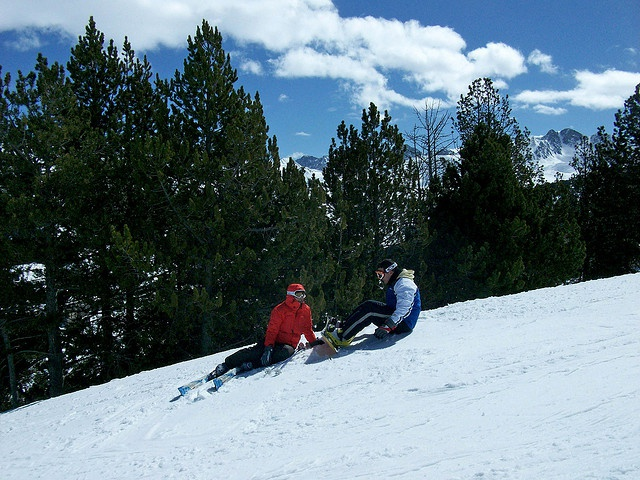Describe the objects in this image and their specific colors. I can see people in lightblue, black, navy, and gray tones, people in lightblue, black, maroon, brown, and gray tones, skis in lightblue, darkgray, blue, gray, and lightgray tones, and snowboard in lightblue, black, gray, darkgreen, and lightgray tones in this image. 